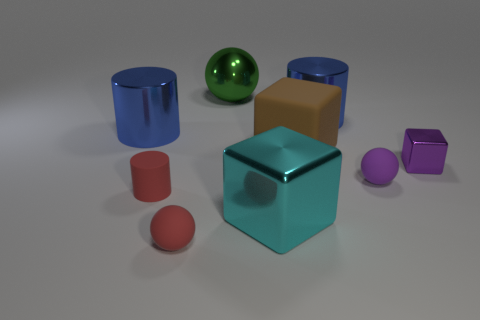Subtract all shiny cylinders. How many cylinders are left? 1 Subtract all blue cylinders. How many cylinders are left? 1 Subtract all green cubes. How many blue cylinders are left? 2 Subtract 1 cylinders. How many cylinders are left? 2 Subtract 0 yellow cylinders. How many objects are left? 9 Subtract all cylinders. How many objects are left? 6 Subtract all gray cylinders. Subtract all cyan balls. How many cylinders are left? 3 Subtract all small cyan matte objects. Subtract all matte things. How many objects are left? 5 Add 8 big cylinders. How many big cylinders are left? 10 Add 7 spheres. How many spheres exist? 10 